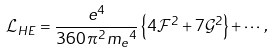<formula> <loc_0><loc_0><loc_500><loc_500>\mathcal { L } _ { H E } = \frac { e ^ { 4 } } { 3 6 0 \, \pi ^ { 2 } { m _ { e } } ^ { 4 } } \left \{ 4 \mathcal { F } ^ { 2 } + 7 \mathcal { G } ^ { 2 } \right \} + \cdots \, ,</formula> 